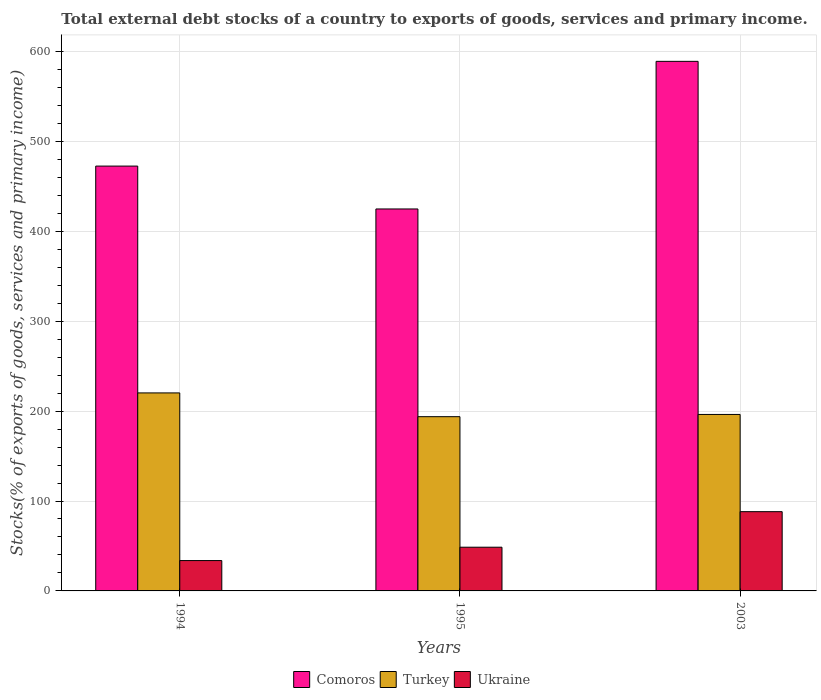How many groups of bars are there?
Ensure brevity in your answer.  3. Are the number of bars per tick equal to the number of legend labels?
Provide a succinct answer. Yes. How many bars are there on the 3rd tick from the left?
Provide a short and direct response. 3. How many bars are there on the 3rd tick from the right?
Offer a very short reply. 3. What is the label of the 3rd group of bars from the left?
Offer a very short reply. 2003. In how many cases, is the number of bars for a given year not equal to the number of legend labels?
Offer a very short reply. 0. What is the total debt stocks in Turkey in 2003?
Make the answer very short. 196.29. Across all years, what is the maximum total debt stocks in Comoros?
Your answer should be very brief. 589.02. Across all years, what is the minimum total debt stocks in Comoros?
Ensure brevity in your answer.  424.83. In which year was the total debt stocks in Comoros maximum?
Your response must be concise. 2003. In which year was the total debt stocks in Turkey minimum?
Keep it short and to the point. 1995. What is the total total debt stocks in Comoros in the graph?
Provide a succinct answer. 1486.38. What is the difference between the total debt stocks in Comoros in 1994 and that in 2003?
Provide a short and direct response. -116.49. What is the difference between the total debt stocks in Ukraine in 2003 and the total debt stocks in Comoros in 1995?
Provide a succinct answer. -336.67. What is the average total debt stocks in Comoros per year?
Your answer should be very brief. 495.46. In the year 1995, what is the difference between the total debt stocks in Comoros and total debt stocks in Turkey?
Offer a terse response. 231.03. What is the ratio of the total debt stocks in Ukraine in 1995 to that in 2003?
Give a very brief answer. 0.55. Is the total debt stocks in Comoros in 1995 less than that in 2003?
Provide a succinct answer. Yes. Is the difference between the total debt stocks in Comoros in 1994 and 2003 greater than the difference between the total debt stocks in Turkey in 1994 and 2003?
Keep it short and to the point. No. What is the difference between the highest and the second highest total debt stocks in Comoros?
Make the answer very short. 116.49. What is the difference between the highest and the lowest total debt stocks in Turkey?
Ensure brevity in your answer.  26.43. Is the sum of the total debt stocks in Comoros in 1994 and 2003 greater than the maximum total debt stocks in Turkey across all years?
Your answer should be compact. Yes. What does the 3rd bar from the right in 2003 represents?
Offer a very short reply. Comoros. How many bars are there?
Provide a succinct answer. 9. Are all the bars in the graph horizontal?
Give a very brief answer. No. How many years are there in the graph?
Provide a short and direct response. 3. Does the graph contain any zero values?
Offer a terse response. No. Does the graph contain grids?
Offer a very short reply. Yes. Where does the legend appear in the graph?
Ensure brevity in your answer.  Bottom center. What is the title of the graph?
Keep it short and to the point. Total external debt stocks of a country to exports of goods, services and primary income. What is the label or title of the X-axis?
Offer a very short reply. Years. What is the label or title of the Y-axis?
Ensure brevity in your answer.  Stocks(% of exports of goods, services and primary income). What is the Stocks(% of exports of goods, services and primary income) of Comoros in 1994?
Ensure brevity in your answer.  472.53. What is the Stocks(% of exports of goods, services and primary income) in Turkey in 1994?
Ensure brevity in your answer.  220.24. What is the Stocks(% of exports of goods, services and primary income) in Ukraine in 1994?
Give a very brief answer. 33.75. What is the Stocks(% of exports of goods, services and primary income) of Comoros in 1995?
Make the answer very short. 424.83. What is the Stocks(% of exports of goods, services and primary income) in Turkey in 1995?
Give a very brief answer. 193.8. What is the Stocks(% of exports of goods, services and primary income) of Ukraine in 1995?
Offer a very short reply. 48.62. What is the Stocks(% of exports of goods, services and primary income) of Comoros in 2003?
Provide a succinct answer. 589.02. What is the Stocks(% of exports of goods, services and primary income) in Turkey in 2003?
Ensure brevity in your answer.  196.29. What is the Stocks(% of exports of goods, services and primary income) in Ukraine in 2003?
Make the answer very short. 88.16. Across all years, what is the maximum Stocks(% of exports of goods, services and primary income) of Comoros?
Keep it short and to the point. 589.02. Across all years, what is the maximum Stocks(% of exports of goods, services and primary income) of Turkey?
Your response must be concise. 220.24. Across all years, what is the maximum Stocks(% of exports of goods, services and primary income) in Ukraine?
Make the answer very short. 88.16. Across all years, what is the minimum Stocks(% of exports of goods, services and primary income) in Comoros?
Your answer should be very brief. 424.83. Across all years, what is the minimum Stocks(% of exports of goods, services and primary income) of Turkey?
Offer a very short reply. 193.8. Across all years, what is the minimum Stocks(% of exports of goods, services and primary income) of Ukraine?
Make the answer very short. 33.75. What is the total Stocks(% of exports of goods, services and primary income) in Comoros in the graph?
Your answer should be compact. 1486.38. What is the total Stocks(% of exports of goods, services and primary income) in Turkey in the graph?
Ensure brevity in your answer.  610.33. What is the total Stocks(% of exports of goods, services and primary income) in Ukraine in the graph?
Give a very brief answer. 170.53. What is the difference between the Stocks(% of exports of goods, services and primary income) of Comoros in 1994 and that in 1995?
Your answer should be very brief. 47.7. What is the difference between the Stocks(% of exports of goods, services and primary income) of Turkey in 1994 and that in 1995?
Make the answer very short. 26.43. What is the difference between the Stocks(% of exports of goods, services and primary income) in Ukraine in 1994 and that in 1995?
Offer a very short reply. -14.87. What is the difference between the Stocks(% of exports of goods, services and primary income) of Comoros in 1994 and that in 2003?
Your answer should be compact. -116.49. What is the difference between the Stocks(% of exports of goods, services and primary income) in Turkey in 1994 and that in 2003?
Provide a succinct answer. 23.94. What is the difference between the Stocks(% of exports of goods, services and primary income) in Ukraine in 1994 and that in 2003?
Offer a very short reply. -54.4. What is the difference between the Stocks(% of exports of goods, services and primary income) of Comoros in 1995 and that in 2003?
Provide a succinct answer. -164.19. What is the difference between the Stocks(% of exports of goods, services and primary income) in Turkey in 1995 and that in 2003?
Give a very brief answer. -2.49. What is the difference between the Stocks(% of exports of goods, services and primary income) in Ukraine in 1995 and that in 2003?
Make the answer very short. -39.54. What is the difference between the Stocks(% of exports of goods, services and primary income) in Comoros in 1994 and the Stocks(% of exports of goods, services and primary income) in Turkey in 1995?
Make the answer very short. 278.72. What is the difference between the Stocks(% of exports of goods, services and primary income) of Comoros in 1994 and the Stocks(% of exports of goods, services and primary income) of Ukraine in 1995?
Provide a succinct answer. 423.91. What is the difference between the Stocks(% of exports of goods, services and primary income) in Turkey in 1994 and the Stocks(% of exports of goods, services and primary income) in Ukraine in 1995?
Keep it short and to the point. 171.62. What is the difference between the Stocks(% of exports of goods, services and primary income) in Comoros in 1994 and the Stocks(% of exports of goods, services and primary income) in Turkey in 2003?
Give a very brief answer. 276.23. What is the difference between the Stocks(% of exports of goods, services and primary income) of Comoros in 1994 and the Stocks(% of exports of goods, services and primary income) of Ukraine in 2003?
Your response must be concise. 384.37. What is the difference between the Stocks(% of exports of goods, services and primary income) of Turkey in 1994 and the Stocks(% of exports of goods, services and primary income) of Ukraine in 2003?
Offer a very short reply. 132.08. What is the difference between the Stocks(% of exports of goods, services and primary income) of Comoros in 1995 and the Stocks(% of exports of goods, services and primary income) of Turkey in 2003?
Provide a succinct answer. 228.54. What is the difference between the Stocks(% of exports of goods, services and primary income) of Comoros in 1995 and the Stocks(% of exports of goods, services and primary income) of Ukraine in 2003?
Ensure brevity in your answer.  336.67. What is the difference between the Stocks(% of exports of goods, services and primary income) of Turkey in 1995 and the Stocks(% of exports of goods, services and primary income) of Ukraine in 2003?
Provide a short and direct response. 105.65. What is the average Stocks(% of exports of goods, services and primary income) of Comoros per year?
Ensure brevity in your answer.  495.46. What is the average Stocks(% of exports of goods, services and primary income) in Turkey per year?
Provide a short and direct response. 203.44. What is the average Stocks(% of exports of goods, services and primary income) in Ukraine per year?
Your answer should be compact. 56.84. In the year 1994, what is the difference between the Stocks(% of exports of goods, services and primary income) in Comoros and Stocks(% of exports of goods, services and primary income) in Turkey?
Ensure brevity in your answer.  252.29. In the year 1994, what is the difference between the Stocks(% of exports of goods, services and primary income) of Comoros and Stocks(% of exports of goods, services and primary income) of Ukraine?
Your response must be concise. 438.77. In the year 1994, what is the difference between the Stocks(% of exports of goods, services and primary income) in Turkey and Stocks(% of exports of goods, services and primary income) in Ukraine?
Provide a short and direct response. 186.48. In the year 1995, what is the difference between the Stocks(% of exports of goods, services and primary income) in Comoros and Stocks(% of exports of goods, services and primary income) in Turkey?
Provide a short and direct response. 231.03. In the year 1995, what is the difference between the Stocks(% of exports of goods, services and primary income) of Comoros and Stocks(% of exports of goods, services and primary income) of Ukraine?
Ensure brevity in your answer.  376.21. In the year 1995, what is the difference between the Stocks(% of exports of goods, services and primary income) in Turkey and Stocks(% of exports of goods, services and primary income) in Ukraine?
Offer a terse response. 145.18. In the year 2003, what is the difference between the Stocks(% of exports of goods, services and primary income) of Comoros and Stocks(% of exports of goods, services and primary income) of Turkey?
Ensure brevity in your answer.  392.72. In the year 2003, what is the difference between the Stocks(% of exports of goods, services and primary income) in Comoros and Stocks(% of exports of goods, services and primary income) in Ukraine?
Offer a terse response. 500.86. In the year 2003, what is the difference between the Stocks(% of exports of goods, services and primary income) in Turkey and Stocks(% of exports of goods, services and primary income) in Ukraine?
Your answer should be very brief. 108.13. What is the ratio of the Stocks(% of exports of goods, services and primary income) in Comoros in 1994 to that in 1995?
Make the answer very short. 1.11. What is the ratio of the Stocks(% of exports of goods, services and primary income) of Turkey in 1994 to that in 1995?
Give a very brief answer. 1.14. What is the ratio of the Stocks(% of exports of goods, services and primary income) in Ukraine in 1994 to that in 1995?
Your answer should be compact. 0.69. What is the ratio of the Stocks(% of exports of goods, services and primary income) in Comoros in 1994 to that in 2003?
Offer a terse response. 0.8. What is the ratio of the Stocks(% of exports of goods, services and primary income) in Turkey in 1994 to that in 2003?
Offer a terse response. 1.12. What is the ratio of the Stocks(% of exports of goods, services and primary income) in Ukraine in 1994 to that in 2003?
Provide a short and direct response. 0.38. What is the ratio of the Stocks(% of exports of goods, services and primary income) of Comoros in 1995 to that in 2003?
Offer a very short reply. 0.72. What is the ratio of the Stocks(% of exports of goods, services and primary income) in Turkey in 1995 to that in 2003?
Offer a very short reply. 0.99. What is the ratio of the Stocks(% of exports of goods, services and primary income) in Ukraine in 1995 to that in 2003?
Your response must be concise. 0.55. What is the difference between the highest and the second highest Stocks(% of exports of goods, services and primary income) of Comoros?
Ensure brevity in your answer.  116.49. What is the difference between the highest and the second highest Stocks(% of exports of goods, services and primary income) of Turkey?
Provide a succinct answer. 23.94. What is the difference between the highest and the second highest Stocks(% of exports of goods, services and primary income) of Ukraine?
Provide a succinct answer. 39.54. What is the difference between the highest and the lowest Stocks(% of exports of goods, services and primary income) of Comoros?
Keep it short and to the point. 164.19. What is the difference between the highest and the lowest Stocks(% of exports of goods, services and primary income) in Turkey?
Provide a succinct answer. 26.43. What is the difference between the highest and the lowest Stocks(% of exports of goods, services and primary income) of Ukraine?
Provide a short and direct response. 54.4. 